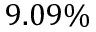<formula> <loc_0><loc_0><loc_500><loc_500>9 . 0 9 \%</formula> 